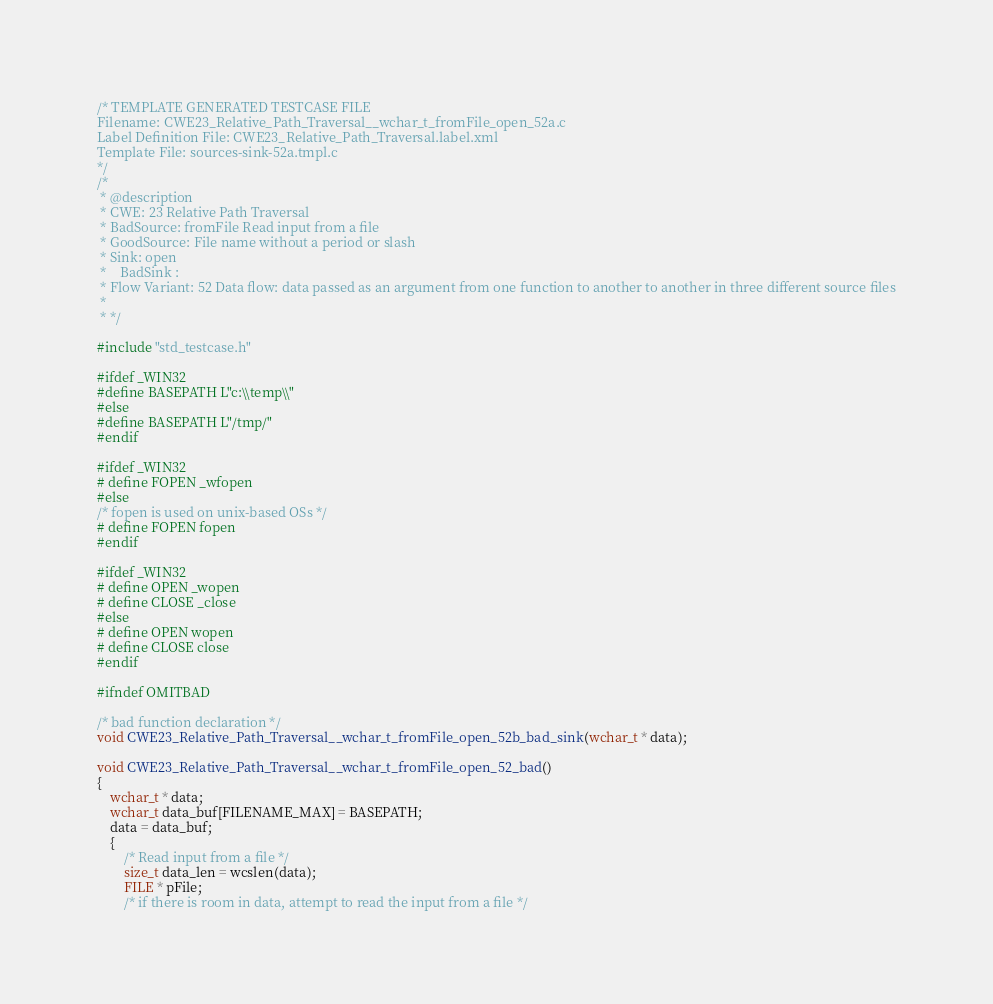<code> <loc_0><loc_0><loc_500><loc_500><_C_>/* TEMPLATE GENERATED TESTCASE FILE
Filename: CWE23_Relative_Path_Traversal__wchar_t_fromFile_open_52a.c
Label Definition File: CWE23_Relative_Path_Traversal.label.xml
Template File: sources-sink-52a.tmpl.c
*/
/*
 * @description
 * CWE: 23 Relative Path Traversal
 * BadSource: fromFile Read input from a file
 * GoodSource: File name without a period or slash
 * Sink: open
 *    BadSink :
 * Flow Variant: 52 Data flow: data passed as an argument from one function to another to another in three different source files
 *
 * */

#include "std_testcase.h"

#ifdef _WIN32
#define BASEPATH L"c:\\temp\\"
#else
#define BASEPATH L"/tmp/"
#endif

#ifdef _WIN32
# define FOPEN _wfopen
#else
/* fopen is used on unix-based OSs */
# define FOPEN fopen
#endif

#ifdef _WIN32
# define OPEN _wopen
# define CLOSE _close
#else
# define OPEN wopen
# define CLOSE close
#endif

#ifndef OMITBAD

/* bad function declaration */
void CWE23_Relative_Path_Traversal__wchar_t_fromFile_open_52b_bad_sink(wchar_t * data);

void CWE23_Relative_Path_Traversal__wchar_t_fromFile_open_52_bad()
{
    wchar_t * data;
    wchar_t data_buf[FILENAME_MAX] = BASEPATH;
    data = data_buf;
    {
        /* Read input from a file */
        size_t data_len = wcslen(data);
        FILE * pFile;
        /* if there is room in data, attempt to read the input from a file */</code> 